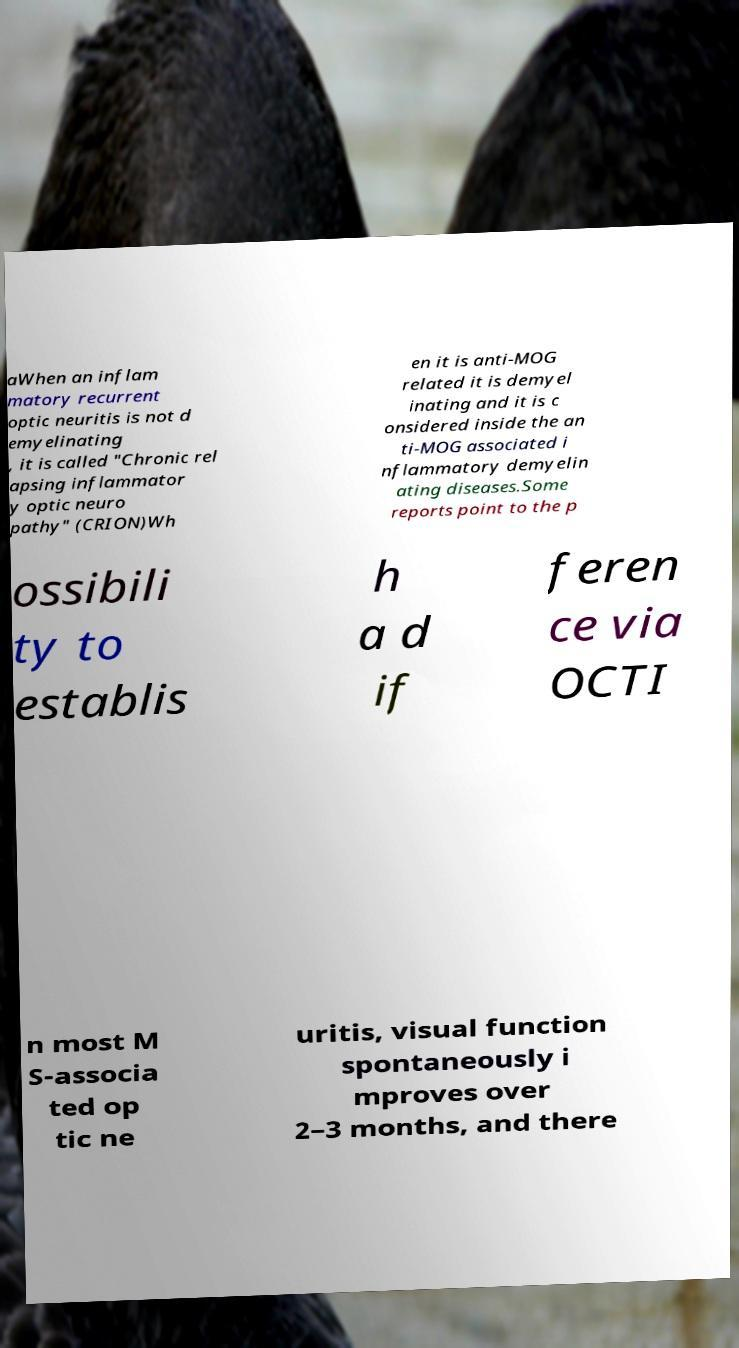I need the written content from this picture converted into text. Can you do that? aWhen an inflam matory recurrent optic neuritis is not d emyelinating , it is called "Chronic rel apsing inflammator y optic neuro pathy" (CRION)Wh en it is anti-MOG related it is demyel inating and it is c onsidered inside the an ti-MOG associated i nflammatory demyelin ating diseases.Some reports point to the p ossibili ty to establis h a d if feren ce via OCTI n most M S-associa ted op tic ne uritis, visual function spontaneously i mproves over 2–3 months, and there 